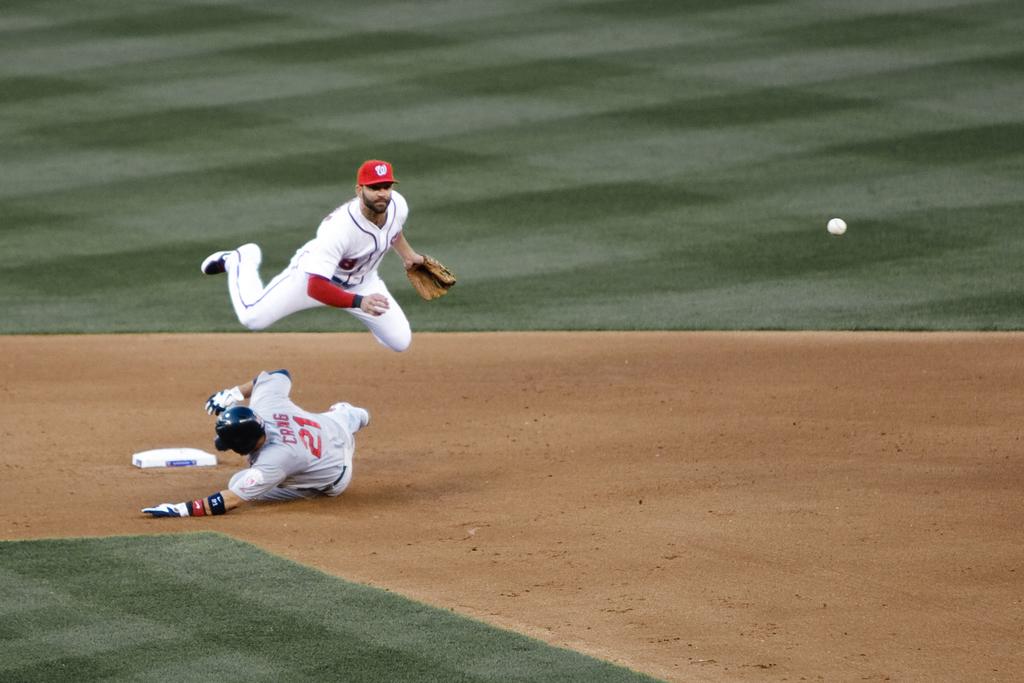What player number is the player on the bottom?
Your answer should be compact. 21. 